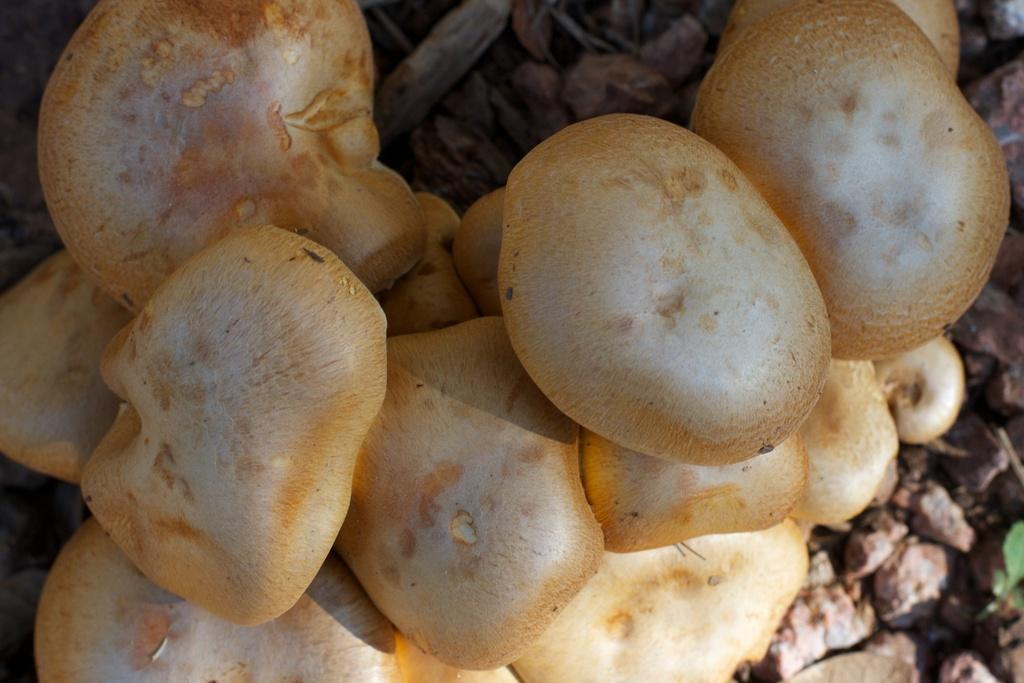Can you describe this image briefly? In this image in the foreground there are some mushrooms, and in the background there are some stones and dry grass. 